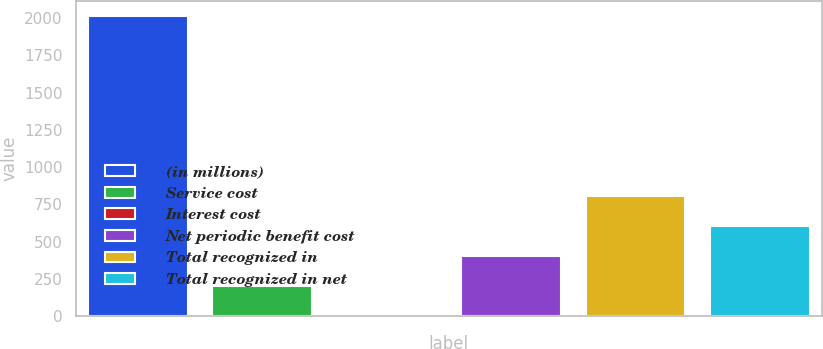<chart> <loc_0><loc_0><loc_500><loc_500><bar_chart><fcel>(in millions)<fcel>Service cost<fcel>Interest cost<fcel>Net periodic benefit cost<fcel>Total recognized in<fcel>Total recognized in net<nl><fcel>2013<fcel>203.1<fcel>2<fcel>404.2<fcel>806.4<fcel>605.3<nl></chart> 